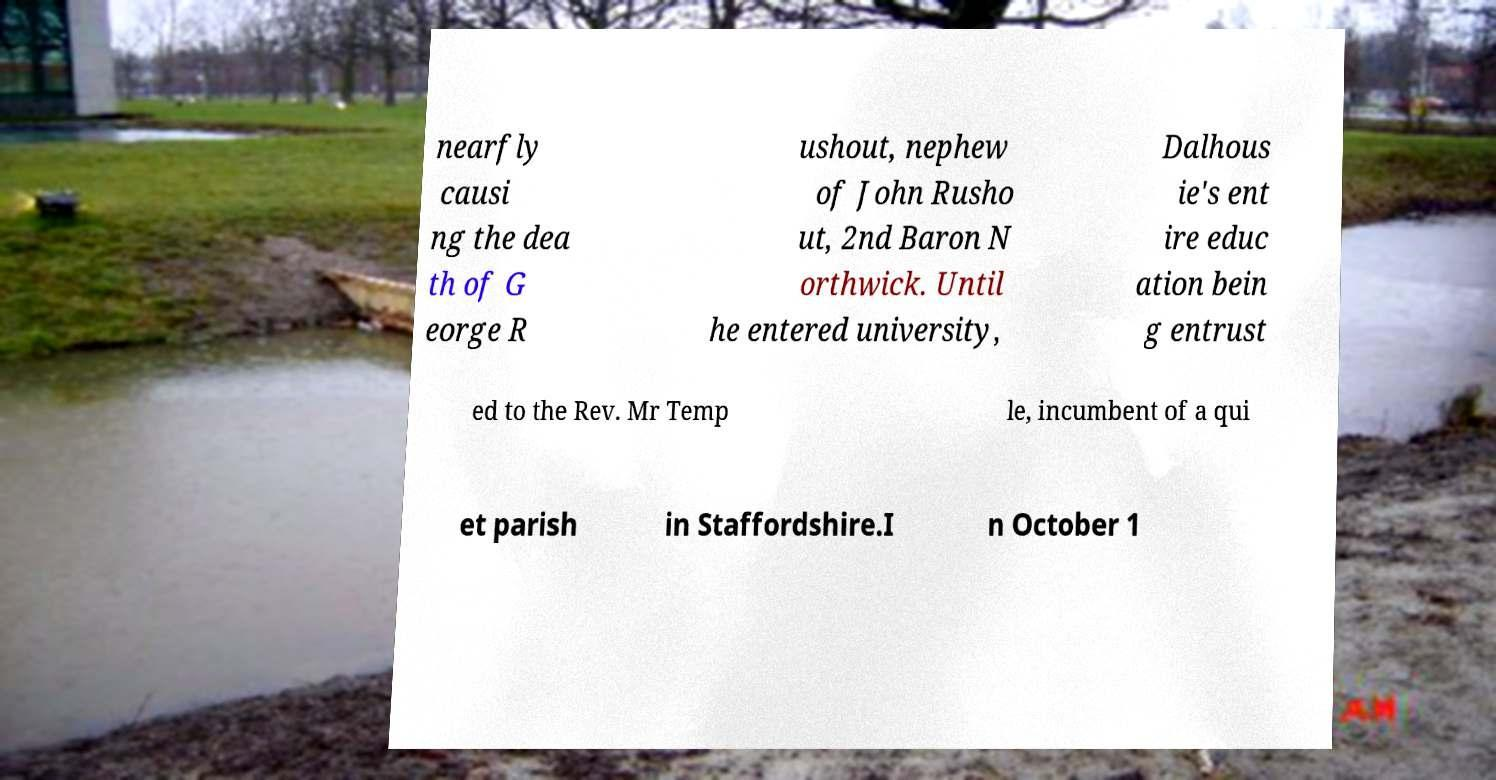I need the written content from this picture converted into text. Can you do that? nearfly causi ng the dea th of G eorge R ushout, nephew of John Rusho ut, 2nd Baron N orthwick. Until he entered university, Dalhous ie's ent ire educ ation bein g entrust ed to the Rev. Mr Temp le, incumbent of a qui et parish in Staffordshire.I n October 1 